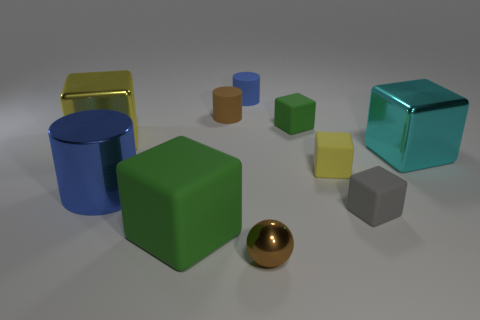There is another cylinder that is the same color as the large metal cylinder; what is its material?
Your response must be concise. Rubber. Are there more metallic balls that are right of the small brown sphere than tiny red objects?
Your response must be concise. No. Are there the same number of blue metallic objects that are in front of the large shiny cylinder and yellow things that are left of the tiny blue rubber object?
Offer a terse response. No. The metallic thing that is on the left side of the brown rubber cylinder and in front of the cyan metal cube is what color?
Your answer should be compact. Blue. Is there anything else that is the same size as the cyan metallic object?
Provide a succinct answer. Yes. Are there more small yellow things on the right side of the gray rubber cube than big metallic blocks on the right side of the tiny green matte thing?
Give a very brief answer. No. Is the size of the green rubber thing that is in front of the cyan metal thing the same as the tiny brown rubber cylinder?
Your answer should be compact. No. How many large yellow cubes are right of the blue thing behind the blue thing in front of the yellow metal block?
Offer a terse response. 0. There is a block that is right of the big yellow block and behind the large cyan block; how big is it?
Provide a succinct answer. Small. What number of other things are the same shape as the tiny brown matte thing?
Provide a short and direct response. 2. 